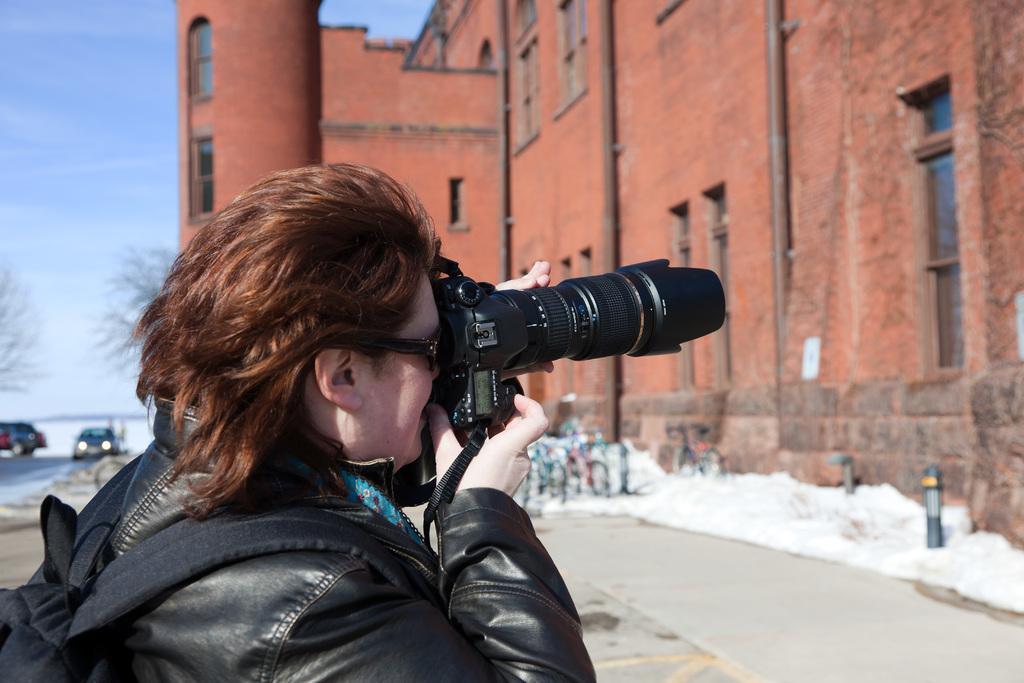Could you give a brief overview of what you see in this image? In this image in the front there is a person holding a camera in his hand and clicking a photo and wearing a bag which is black in colour. In the background there are cars, dry trees and there is a castle. 